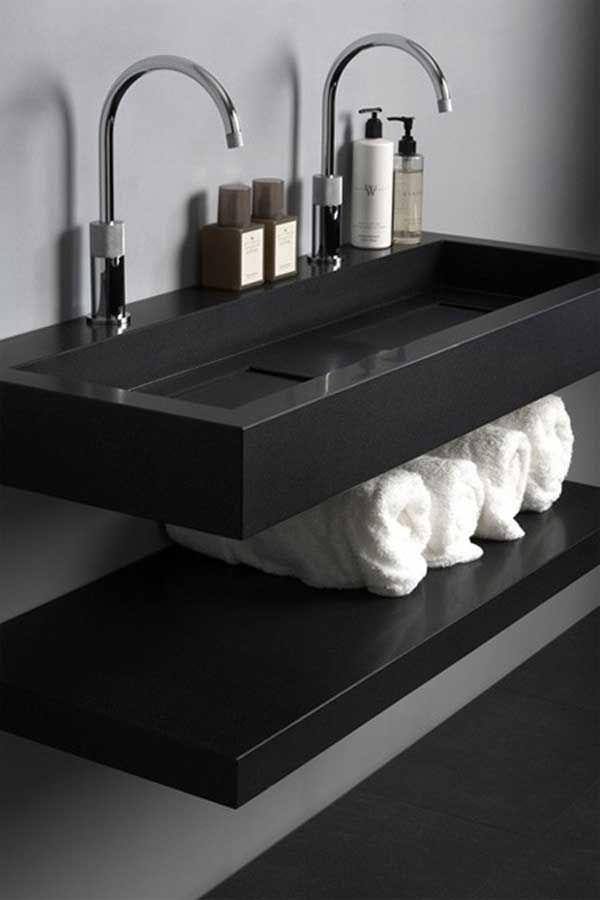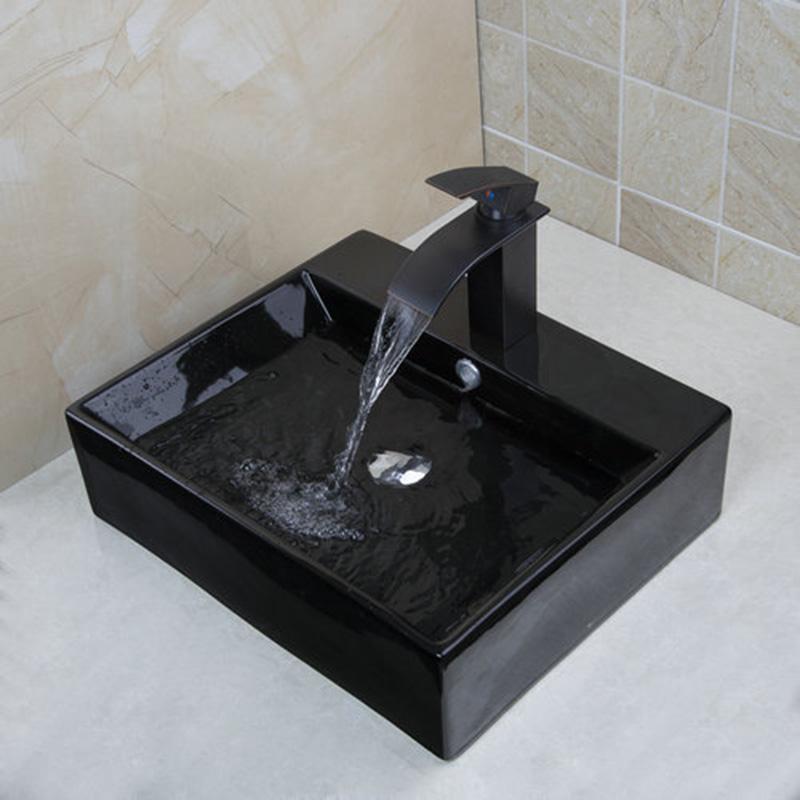The first image is the image on the left, the second image is the image on the right. Given the left and right images, does the statement "The two images show a somewhat round bowl sink and a rectangular inset sink." hold true? Answer yes or no. No. 